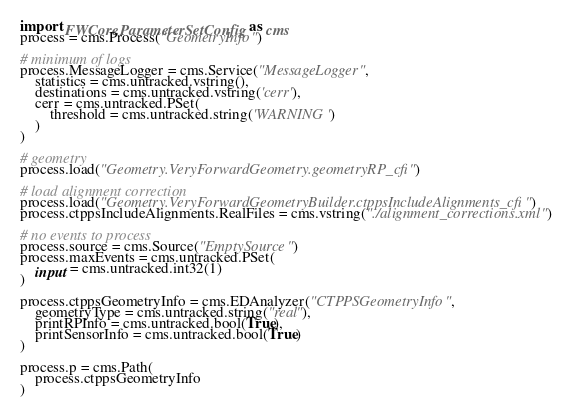<code> <loc_0><loc_0><loc_500><loc_500><_Python_>import FWCore.ParameterSet.Config as cms
process = cms.Process("GeometryInfo")

# minimum of logs
process.MessageLogger = cms.Service("MessageLogger",
    statistics = cms.untracked.vstring(),
    destinations = cms.untracked.vstring('cerr'),
    cerr = cms.untracked.PSet(
        threshold = cms.untracked.string('WARNING')
    )
)

# geometry
process.load("Geometry.VeryForwardGeometry.geometryRP_cfi")

# load alignment correction
process.load("Geometry.VeryForwardGeometryBuilder.ctppsIncludeAlignments_cfi")
process.ctppsIncludeAlignments.RealFiles = cms.vstring("./alignment_corrections.xml")

# no events to process
process.source = cms.Source("EmptySource")
process.maxEvents = cms.untracked.PSet(
    input = cms.untracked.int32(1)
)

process.ctppsGeometryInfo = cms.EDAnalyzer("CTPPSGeometryInfo",
    geometryType = cms.untracked.string("real"),
    printRPInfo = cms.untracked.bool(True),
    printSensorInfo = cms.untracked.bool(True)
)

process.p = cms.Path(
    process.ctppsGeometryInfo
)
</code> 